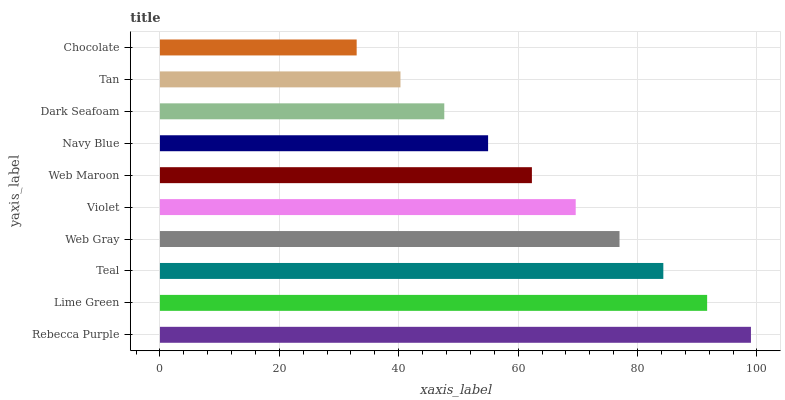Is Chocolate the minimum?
Answer yes or no. Yes. Is Rebecca Purple the maximum?
Answer yes or no. Yes. Is Lime Green the minimum?
Answer yes or no. No. Is Lime Green the maximum?
Answer yes or no. No. Is Rebecca Purple greater than Lime Green?
Answer yes or no. Yes. Is Lime Green less than Rebecca Purple?
Answer yes or no. Yes. Is Lime Green greater than Rebecca Purple?
Answer yes or no. No. Is Rebecca Purple less than Lime Green?
Answer yes or no. No. Is Violet the high median?
Answer yes or no. Yes. Is Web Maroon the low median?
Answer yes or no. Yes. Is Web Gray the high median?
Answer yes or no. No. Is Violet the low median?
Answer yes or no. No. 